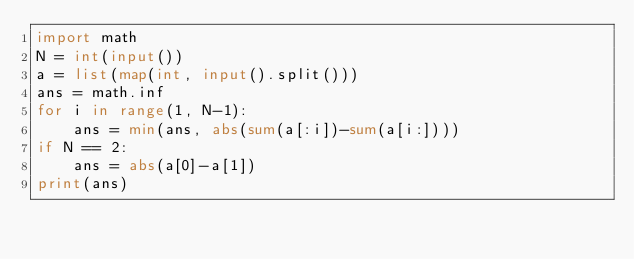<code> <loc_0><loc_0><loc_500><loc_500><_Python_>import math
N = int(input())
a = list(map(int, input().split()))
ans = math.inf
for i in range(1, N-1):
    ans = min(ans, abs(sum(a[:i])-sum(a[i:])))
if N == 2:
    ans = abs(a[0]-a[1])
print(ans)
</code> 